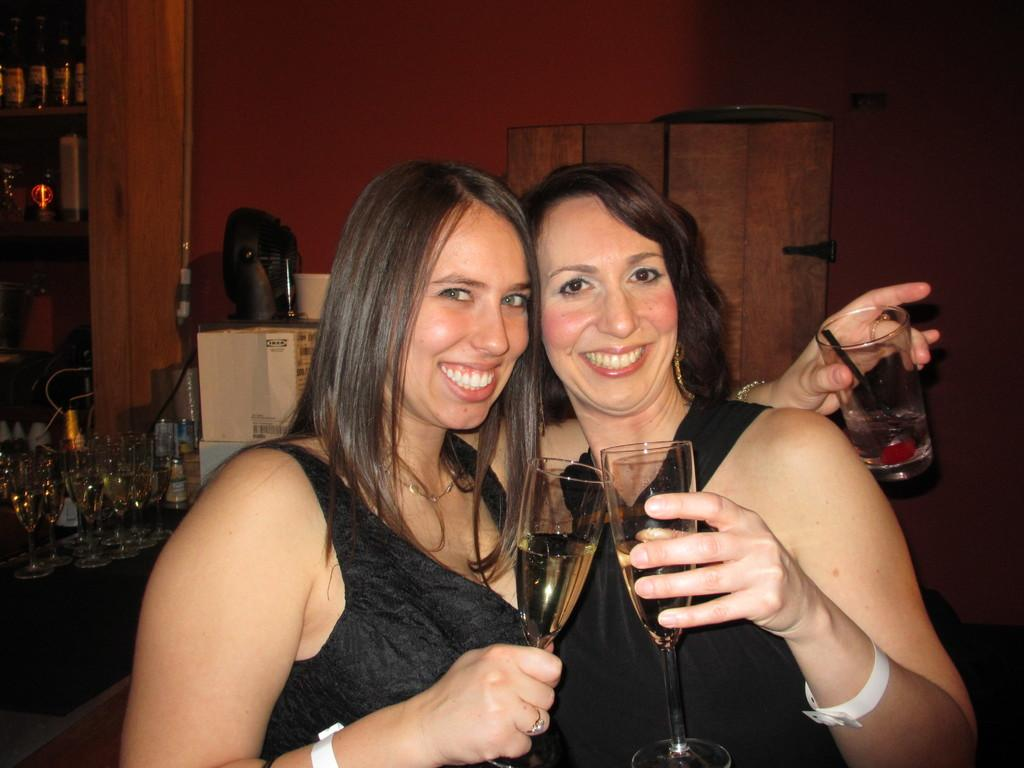How many women are in the image? There are two women in the image. What are the women doing in the image? The women are standing with smiles on their faces. What are the women holding in their hands? The women are holding wine glasses in their hands. What else can be seen in the background of the image? There are bottles and glasses visible in the background of the image. What street are the women standing on in the image? There is no mention of a street in the image. 